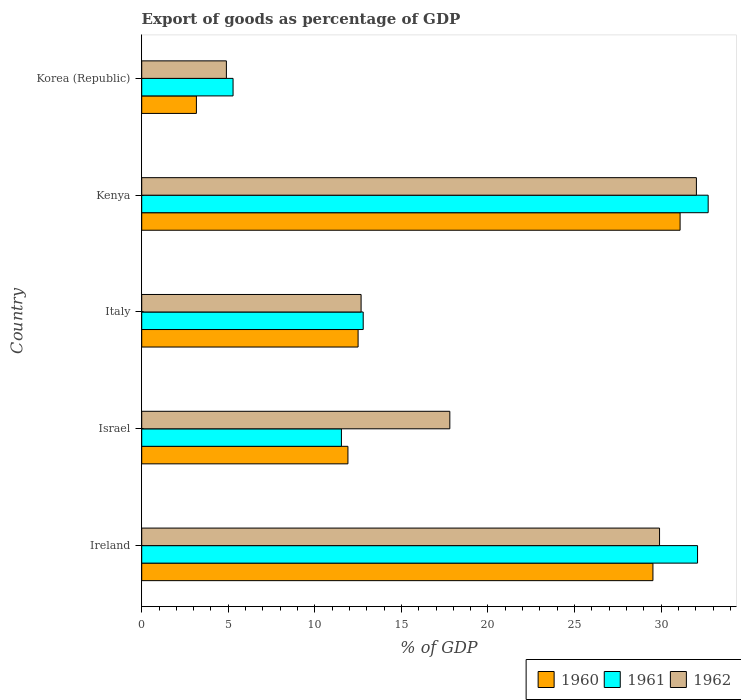How many groups of bars are there?
Make the answer very short. 5. Are the number of bars per tick equal to the number of legend labels?
Your response must be concise. Yes. How many bars are there on the 1st tick from the bottom?
Give a very brief answer. 3. What is the label of the 5th group of bars from the top?
Ensure brevity in your answer.  Ireland. In how many cases, is the number of bars for a given country not equal to the number of legend labels?
Ensure brevity in your answer.  0. What is the export of goods as percentage of GDP in 1962 in Korea (Republic)?
Offer a terse response. 4.89. Across all countries, what is the maximum export of goods as percentage of GDP in 1962?
Make the answer very short. 32.04. Across all countries, what is the minimum export of goods as percentage of GDP in 1961?
Give a very brief answer. 5.28. In which country was the export of goods as percentage of GDP in 1962 maximum?
Keep it short and to the point. Kenya. In which country was the export of goods as percentage of GDP in 1962 minimum?
Offer a terse response. Korea (Republic). What is the total export of goods as percentage of GDP in 1961 in the graph?
Give a very brief answer. 94.42. What is the difference between the export of goods as percentage of GDP in 1962 in Ireland and that in Korea (Republic)?
Provide a succinct answer. 25.02. What is the difference between the export of goods as percentage of GDP in 1961 in Italy and the export of goods as percentage of GDP in 1962 in Ireland?
Provide a succinct answer. -17.12. What is the average export of goods as percentage of GDP in 1960 per country?
Your response must be concise. 17.64. What is the difference between the export of goods as percentage of GDP in 1961 and export of goods as percentage of GDP in 1960 in Kenya?
Your answer should be very brief. 1.62. In how many countries, is the export of goods as percentage of GDP in 1962 greater than 26 %?
Offer a terse response. 2. What is the ratio of the export of goods as percentage of GDP in 1962 in Israel to that in Korea (Republic)?
Give a very brief answer. 3.64. Is the export of goods as percentage of GDP in 1960 in Israel less than that in Korea (Republic)?
Keep it short and to the point. No. What is the difference between the highest and the second highest export of goods as percentage of GDP in 1960?
Make the answer very short. 1.57. What is the difference between the highest and the lowest export of goods as percentage of GDP in 1961?
Keep it short and to the point. 27.44. In how many countries, is the export of goods as percentage of GDP in 1962 greater than the average export of goods as percentage of GDP in 1962 taken over all countries?
Your response must be concise. 2. Is the sum of the export of goods as percentage of GDP in 1961 in Italy and Kenya greater than the maximum export of goods as percentage of GDP in 1960 across all countries?
Provide a succinct answer. Yes. How many bars are there?
Provide a succinct answer. 15. How many countries are there in the graph?
Offer a very short reply. 5. Does the graph contain any zero values?
Provide a short and direct response. No. Where does the legend appear in the graph?
Your answer should be very brief. Bottom right. How are the legend labels stacked?
Your answer should be compact. Horizontal. What is the title of the graph?
Keep it short and to the point. Export of goods as percentage of GDP. Does "1978" appear as one of the legend labels in the graph?
Ensure brevity in your answer.  No. What is the label or title of the X-axis?
Your answer should be compact. % of GDP. What is the % of GDP in 1960 in Ireland?
Make the answer very short. 29.53. What is the % of GDP in 1961 in Ireland?
Offer a very short reply. 32.1. What is the % of GDP in 1962 in Ireland?
Give a very brief answer. 29.91. What is the % of GDP of 1960 in Israel?
Provide a short and direct response. 11.91. What is the % of GDP in 1961 in Israel?
Ensure brevity in your answer.  11.53. What is the % of GDP in 1962 in Israel?
Provide a succinct answer. 17.8. What is the % of GDP of 1960 in Italy?
Ensure brevity in your answer.  12.5. What is the % of GDP in 1961 in Italy?
Your response must be concise. 12.79. What is the % of GDP of 1962 in Italy?
Provide a short and direct response. 12.67. What is the % of GDP in 1960 in Kenya?
Offer a very short reply. 31.1. What is the % of GDP of 1961 in Kenya?
Keep it short and to the point. 32.72. What is the % of GDP in 1962 in Kenya?
Your response must be concise. 32.04. What is the % of GDP in 1960 in Korea (Republic)?
Offer a very short reply. 3.16. What is the % of GDP in 1961 in Korea (Republic)?
Keep it short and to the point. 5.28. What is the % of GDP in 1962 in Korea (Republic)?
Offer a very short reply. 4.89. Across all countries, what is the maximum % of GDP in 1960?
Your response must be concise. 31.1. Across all countries, what is the maximum % of GDP of 1961?
Your response must be concise. 32.72. Across all countries, what is the maximum % of GDP in 1962?
Provide a succinct answer. 32.04. Across all countries, what is the minimum % of GDP of 1960?
Provide a short and direct response. 3.16. Across all countries, what is the minimum % of GDP in 1961?
Your response must be concise. 5.28. Across all countries, what is the minimum % of GDP in 1962?
Give a very brief answer. 4.89. What is the total % of GDP of 1960 in the graph?
Provide a succinct answer. 88.19. What is the total % of GDP in 1961 in the graph?
Your answer should be very brief. 94.42. What is the total % of GDP in 1962 in the graph?
Provide a short and direct response. 97.3. What is the difference between the % of GDP in 1960 in Ireland and that in Israel?
Give a very brief answer. 17.62. What is the difference between the % of GDP in 1961 in Ireland and that in Israel?
Provide a succinct answer. 20.57. What is the difference between the % of GDP of 1962 in Ireland and that in Israel?
Keep it short and to the point. 12.11. What is the difference between the % of GDP of 1960 in Ireland and that in Italy?
Offer a terse response. 17.03. What is the difference between the % of GDP in 1961 in Ireland and that in Italy?
Keep it short and to the point. 19.31. What is the difference between the % of GDP in 1962 in Ireland and that in Italy?
Offer a very short reply. 17.24. What is the difference between the % of GDP in 1960 in Ireland and that in Kenya?
Provide a short and direct response. -1.57. What is the difference between the % of GDP of 1961 in Ireland and that in Kenya?
Keep it short and to the point. -0.61. What is the difference between the % of GDP in 1962 in Ireland and that in Kenya?
Keep it short and to the point. -2.13. What is the difference between the % of GDP of 1960 in Ireland and that in Korea (Republic)?
Offer a very short reply. 26.37. What is the difference between the % of GDP in 1961 in Ireland and that in Korea (Republic)?
Offer a very short reply. 26.83. What is the difference between the % of GDP of 1962 in Ireland and that in Korea (Republic)?
Offer a terse response. 25.02. What is the difference between the % of GDP of 1960 in Israel and that in Italy?
Give a very brief answer. -0.59. What is the difference between the % of GDP in 1961 in Israel and that in Italy?
Give a very brief answer. -1.26. What is the difference between the % of GDP in 1962 in Israel and that in Italy?
Your answer should be compact. 5.12. What is the difference between the % of GDP of 1960 in Israel and that in Kenya?
Your answer should be very brief. -19.18. What is the difference between the % of GDP of 1961 in Israel and that in Kenya?
Provide a succinct answer. -21.18. What is the difference between the % of GDP in 1962 in Israel and that in Kenya?
Provide a succinct answer. -14.24. What is the difference between the % of GDP in 1960 in Israel and that in Korea (Republic)?
Offer a terse response. 8.75. What is the difference between the % of GDP of 1961 in Israel and that in Korea (Republic)?
Give a very brief answer. 6.26. What is the difference between the % of GDP in 1962 in Israel and that in Korea (Republic)?
Ensure brevity in your answer.  12.91. What is the difference between the % of GDP in 1960 in Italy and that in Kenya?
Make the answer very short. -18.6. What is the difference between the % of GDP in 1961 in Italy and that in Kenya?
Keep it short and to the point. -19.92. What is the difference between the % of GDP of 1962 in Italy and that in Kenya?
Ensure brevity in your answer.  -19.37. What is the difference between the % of GDP of 1960 in Italy and that in Korea (Republic)?
Your answer should be compact. 9.34. What is the difference between the % of GDP in 1961 in Italy and that in Korea (Republic)?
Keep it short and to the point. 7.52. What is the difference between the % of GDP in 1962 in Italy and that in Korea (Republic)?
Your response must be concise. 7.78. What is the difference between the % of GDP of 1960 in Kenya and that in Korea (Republic)?
Your answer should be compact. 27.94. What is the difference between the % of GDP in 1961 in Kenya and that in Korea (Republic)?
Provide a succinct answer. 27.44. What is the difference between the % of GDP in 1962 in Kenya and that in Korea (Republic)?
Your answer should be compact. 27.15. What is the difference between the % of GDP in 1960 in Ireland and the % of GDP in 1961 in Israel?
Offer a terse response. 17.99. What is the difference between the % of GDP of 1960 in Ireland and the % of GDP of 1962 in Israel?
Your answer should be compact. 11.73. What is the difference between the % of GDP in 1961 in Ireland and the % of GDP in 1962 in Israel?
Provide a short and direct response. 14.31. What is the difference between the % of GDP in 1960 in Ireland and the % of GDP in 1961 in Italy?
Your answer should be very brief. 16.73. What is the difference between the % of GDP of 1960 in Ireland and the % of GDP of 1962 in Italy?
Your answer should be very brief. 16.86. What is the difference between the % of GDP in 1961 in Ireland and the % of GDP in 1962 in Italy?
Provide a succinct answer. 19.43. What is the difference between the % of GDP in 1960 in Ireland and the % of GDP in 1961 in Kenya?
Your response must be concise. -3.19. What is the difference between the % of GDP of 1960 in Ireland and the % of GDP of 1962 in Kenya?
Your answer should be very brief. -2.51. What is the difference between the % of GDP of 1961 in Ireland and the % of GDP of 1962 in Kenya?
Provide a short and direct response. 0.07. What is the difference between the % of GDP of 1960 in Ireland and the % of GDP of 1961 in Korea (Republic)?
Your answer should be compact. 24.25. What is the difference between the % of GDP in 1960 in Ireland and the % of GDP in 1962 in Korea (Republic)?
Your answer should be compact. 24.64. What is the difference between the % of GDP of 1961 in Ireland and the % of GDP of 1962 in Korea (Republic)?
Offer a very short reply. 27.21. What is the difference between the % of GDP of 1960 in Israel and the % of GDP of 1961 in Italy?
Your answer should be very brief. -0.88. What is the difference between the % of GDP in 1960 in Israel and the % of GDP in 1962 in Italy?
Provide a short and direct response. -0.76. What is the difference between the % of GDP in 1961 in Israel and the % of GDP in 1962 in Italy?
Offer a terse response. -1.14. What is the difference between the % of GDP of 1960 in Israel and the % of GDP of 1961 in Kenya?
Provide a short and direct response. -20.81. What is the difference between the % of GDP of 1960 in Israel and the % of GDP of 1962 in Kenya?
Your answer should be compact. -20.13. What is the difference between the % of GDP in 1961 in Israel and the % of GDP in 1962 in Kenya?
Keep it short and to the point. -20.5. What is the difference between the % of GDP in 1960 in Israel and the % of GDP in 1961 in Korea (Republic)?
Give a very brief answer. 6.64. What is the difference between the % of GDP of 1960 in Israel and the % of GDP of 1962 in Korea (Republic)?
Offer a terse response. 7.02. What is the difference between the % of GDP of 1961 in Israel and the % of GDP of 1962 in Korea (Republic)?
Keep it short and to the point. 6.64. What is the difference between the % of GDP in 1960 in Italy and the % of GDP in 1961 in Kenya?
Make the answer very short. -20.22. What is the difference between the % of GDP of 1960 in Italy and the % of GDP of 1962 in Kenya?
Make the answer very short. -19.54. What is the difference between the % of GDP in 1961 in Italy and the % of GDP in 1962 in Kenya?
Make the answer very short. -19.25. What is the difference between the % of GDP of 1960 in Italy and the % of GDP of 1961 in Korea (Republic)?
Make the answer very short. 7.22. What is the difference between the % of GDP in 1960 in Italy and the % of GDP in 1962 in Korea (Republic)?
Your answer should be very brief. 7.61. What is the difference between the % of GDP of 1961 in Italy and the % of GDP of 1962 in Korea (Republic)?
Make the answer very short. 7.9. What is the difference between the % of GDP of 1960 in Kenya and the % of GDP of 1961 in Korea (Republic)?
Offer a terse response. 25.82. What is the difference between the % of GDP of 1960 in Kenya and the % of GDP of 1962 in Korea (Republic)?
Offer a terse response. 26.21. What is the difference between the % of GDP of 1961 in Kenya and the % of GDP of 1962 in Korea (Republic)?
Your answer should be very brief. 27.83. What is the average % of GDP of 1960 per country?
Make the answer very short. 17.64. What is the average % of GDP in 1961 per country?
Give a very brief answer. 18.88. What is the average % of GDP in 1962 per country?
Offer a terse response. 19.46. What is the difference between the % of GDP of 1960 and % of GDP of 1961 in Ireland?
Make the answer very short. -2.58. What is the difference between the % of GDP in 1960 and % of GDP in 1962 in Ireland?
Provide a short and direct response. -0.38. What is the difference between the % of GDP in 1961 and % of GDP in 1962 in Ireland?
Provide a succinct answer. 2.2. What is the difference between the % of GDP in 1960 and % of GDP in 1961 in Israel?
Keep it short and to the point. 0.38. What is the difference between the % of GDP in 1960 and % of GDP in 1962 in Israel?
Offer a very short reply. -5.88. What is the difference between the % of GDP in 1961 and % of GDP in 1962 in Israel?
Keep it short and to the point. -6.26. What is the difference between the % of GDP of 1960 and % of GDP of 1961 in Italy?
Ensure brevity in your answer.  -0.29. What is the difference between the % of GDP in 1960 and % of GDP in 1962 in Italy?
Your answer should be very brief. -0.17. What is the difference between the % of GDP of 1961 and % of GDP of 1962 in Italy?
Keep it short and to the point. 0.12. What is the difference between the % of GDP in 1960 and % of GDP in 1961 in Kenya?
Provide a succinct answer. -1.62. What is the difference between the % of GDP in 1960 and % of GDP in 1962 in Kenya?
Offer a very short reply. -0.94. What is the difference between the % of GDP of 1961 and % of GDP of 1962 in Kenya?
Make the answer very short. 0.68. What is the difference between the % of GDP in 1960 and % of GDP in 1961 in Korea (Republic)?
Make the answer very short. -2.12. What is the difference between the % of GDP in 1960 and % of GDP in 1962 in Korea (Republic)?
Offer a very short reply. -1.73. What is the difference between the % of GDP of 1961 and % of GDP of 1962 in Korea (Republic)?
Your response must be concise. 0.39. What is the ratio of the % of GDP in 1960 in Ireland to that in Israel?
Provide a short and direct response. 2.48. What is the ratio of the % of GDP in 1961 in Ireland to that in Israel?
Make the answer very short. 2.78. What is the ratio of the % of GDP in 1962 in Ireland to that in Israel?
Provide a succinct answer. 1.68. What is the ratio of the % of GDP in 1960 in Ireland to that in Italy?
Make the answer very short. 2.36. What is the ratio of the % of GDP of 1961 in Ireland to that in Italy?
Your response must be concise. 2.51. What is the ratio of the % of GDP in 1962 in Ireland to that in Italy?
Offer a very short reply. 2.36. What is the ratio of the % of GDP in 1960 in Ireland to that in Kenya?
Make the answer very short. 0.95. What is the ratio of the % of GDP in 1961 in Ireland to that in Kenya?
Ensure brevity in your answer.  0.98. What is the ratio of the % of GDP of 1962 in Ireland to that in Kenya?
Your answer should be compact. 0.93. What is the ratio of the % of GDP of 1960 in Ireland to that in Korea (Republic)?
Offer a very short reply. 9.35. What is the ratio of the % of GDP of 1961 in Ireland to that in Korea (Republic)?
Offer a very short reply. 6.09. What is the ratio of the % of GDP in 1962 in Ireland to that in Korea (Republic)?
Keep it short and to the point. 6.12. What is the ratio of the % of GDP in 1960 in Israel to that in Italy?
Your answer should be very brief. 0.95. What is the ratio of the % of GDP of 1961 in Israel to that in Italy?
Provide a short and direct response. 0.9. What is the ratio of the % of GDP of 1962 in Israel to that in Italy?
Your response must be concise. 1.4. What is the ratio of the % of GDP in 1960 in Israel to that in Kenya?
Provide a short and direct response. 0.38. What is the ratio of the % of GDP in 1961 in Israel to that in Kenya?
Ensure brevity in your answer.  0.35. What is the ratio of the % of GDP of 1962 in Israel to that in Kenya?
Your answer should be very brief. 0.56. What is the ratio of the % of GDP in 1960 in Israel to that in Korea (Republic)?
Give a very brief answer. 3.77. What is the ratio of the % of GDP in 1961 in Israel to that in Korea (Republic)?
Keep it short and to the point. 2.19. What is the ratio of the % of GDP in 1962 in Israel to that in Korea (Republic)?
Provide a short and direct response. 3.64. What is the ratio of the % of GDP in 1960 in Italy to that in Kenya?
Give a very brief answer. 0.4. What is the ratio of the % of GDP of 1961 in Italy to that in Kenya?
Provide a succinct answer. 0.39. What is the ratio of the % of GDP of 1962 in Italy to that in Kenya?
Your response must be concise. 0.4. What is the ratio of the % of GDP of 1960 in Italy to that in Korea (Republic)?
Offer a terse response. 3.96. What is the ratio of the % of GDP in 1961 in Italy to that in Korea (Republic)?
Provide a succinct answer. 2.42. What is the ratio of the % of GDP in 1962 in Italy to that in Korea (Republic)?
Your response must be concise. 2.59. What is the ratio of the % of GDP in 1960 in Kenya to that in Korea (Republic)?
Provide a short and direct response. 9.85. What is the ratio of the % of GDP in 1961 in Kenya to that in Korea (Republic)?
Offer a terse response. 6.2. What is the ratio of the % of GDP of 1962 in Kenya to that in Korea (Republic)?
Your response must be concise. 6.55. What is the difference between the highest and the second highest % of GDP of 1960?
Make the answer very short. 1.57. What is the difference between the highest and the second highest % of GDP in 1961?
Your response must be concise. 0.61. What is the difference between the highest and the second highest % of GDP in 1962?
Keep it short and to the point. 2.13. What is the difference between the highest and the lowest % of GDP in 1960?
Provide a succinct answer. 27.94. What is the difference between the highest and the lowest % of GDP of 1961?
Your response must be concise. 27.44. What is the difference between the highest and the lowest % of GDP in 1962?
Your response must be concise. 27.15. 